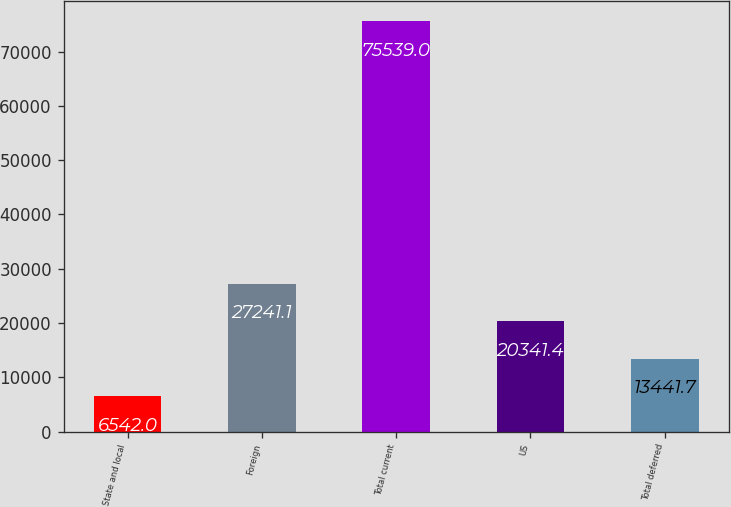Convert chart. <chart><loc_0><loc_0><loc_500><loc_500><bar_chart><fcel>State and local<fcel>Foreign<fcel>Total current<fcel>US<fcel>Total deferred<nl><fcel>6542<fcel>27241.1<fcel>75539<fcel>20341.4<fcel>13441.7<nl></chart> 